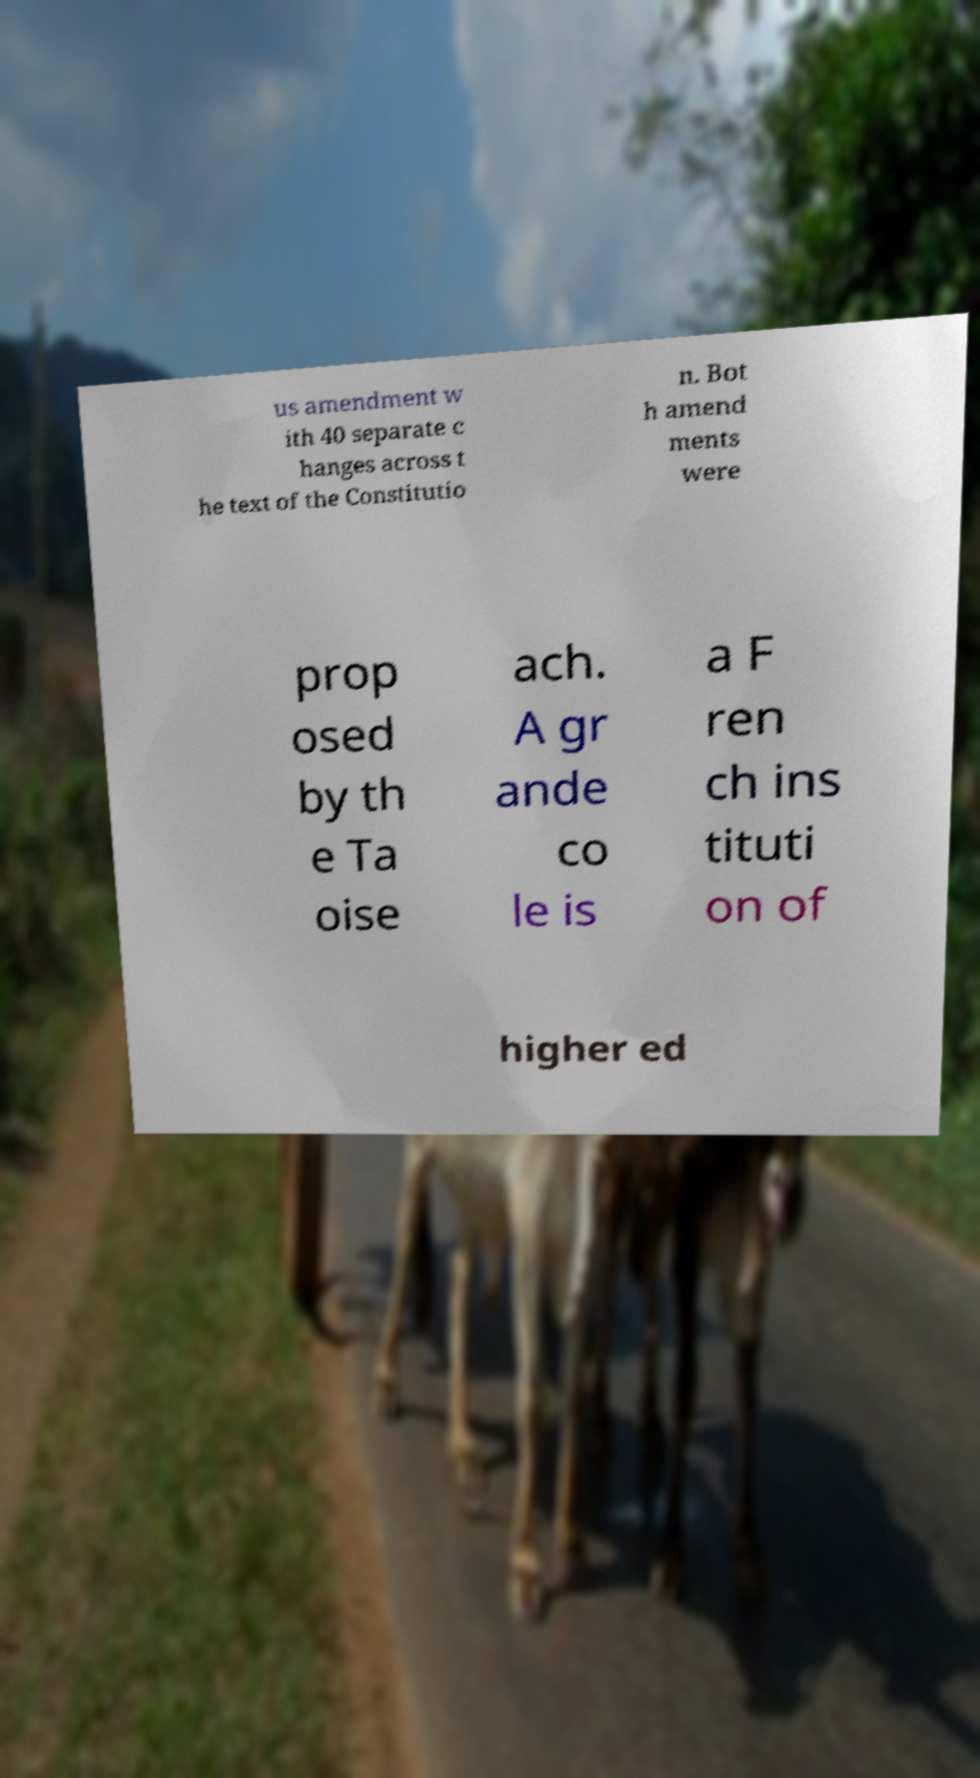I need the written content from this picture converted into text. Can you do that? us amendment w ith 40 separate c hanges across t he text of the Constitutio n. Bot h amend ments were prop osed by th e Ta oise ach. A gr ande co le is a F ren ch ins tituti on of higher ed 